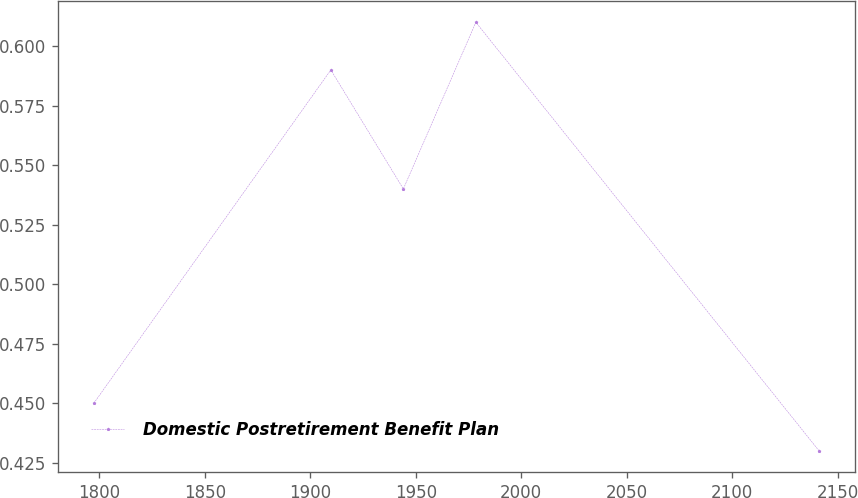Convert chart. <chart><loc_0><loc_0><loc_500><loc_500><line_chart><ecel><fcel>Domestic Postretirement Benefit Plan<nl><fcel>1797.35<fcel>0.45<nl><fcel>1909.72<fcel>0.59<nl><fcel>1944.1<fcel>0.54<nl><fcel>1978.48<fcel>0.61<nl><fcel>2141.19<fcel>0.43<nl></chart> 